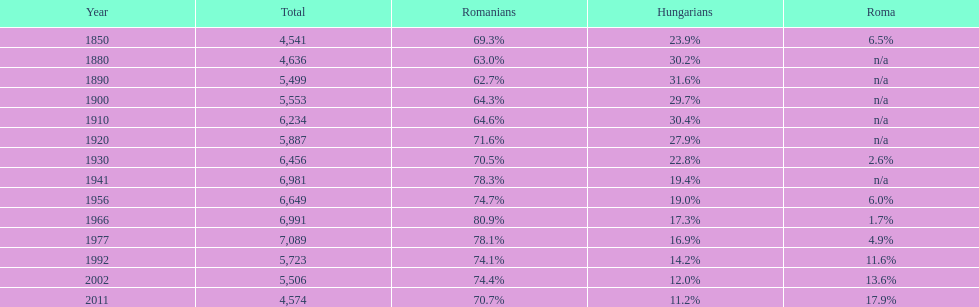What percent of the population were romanians according to the last year on this chart? 70.7%. 